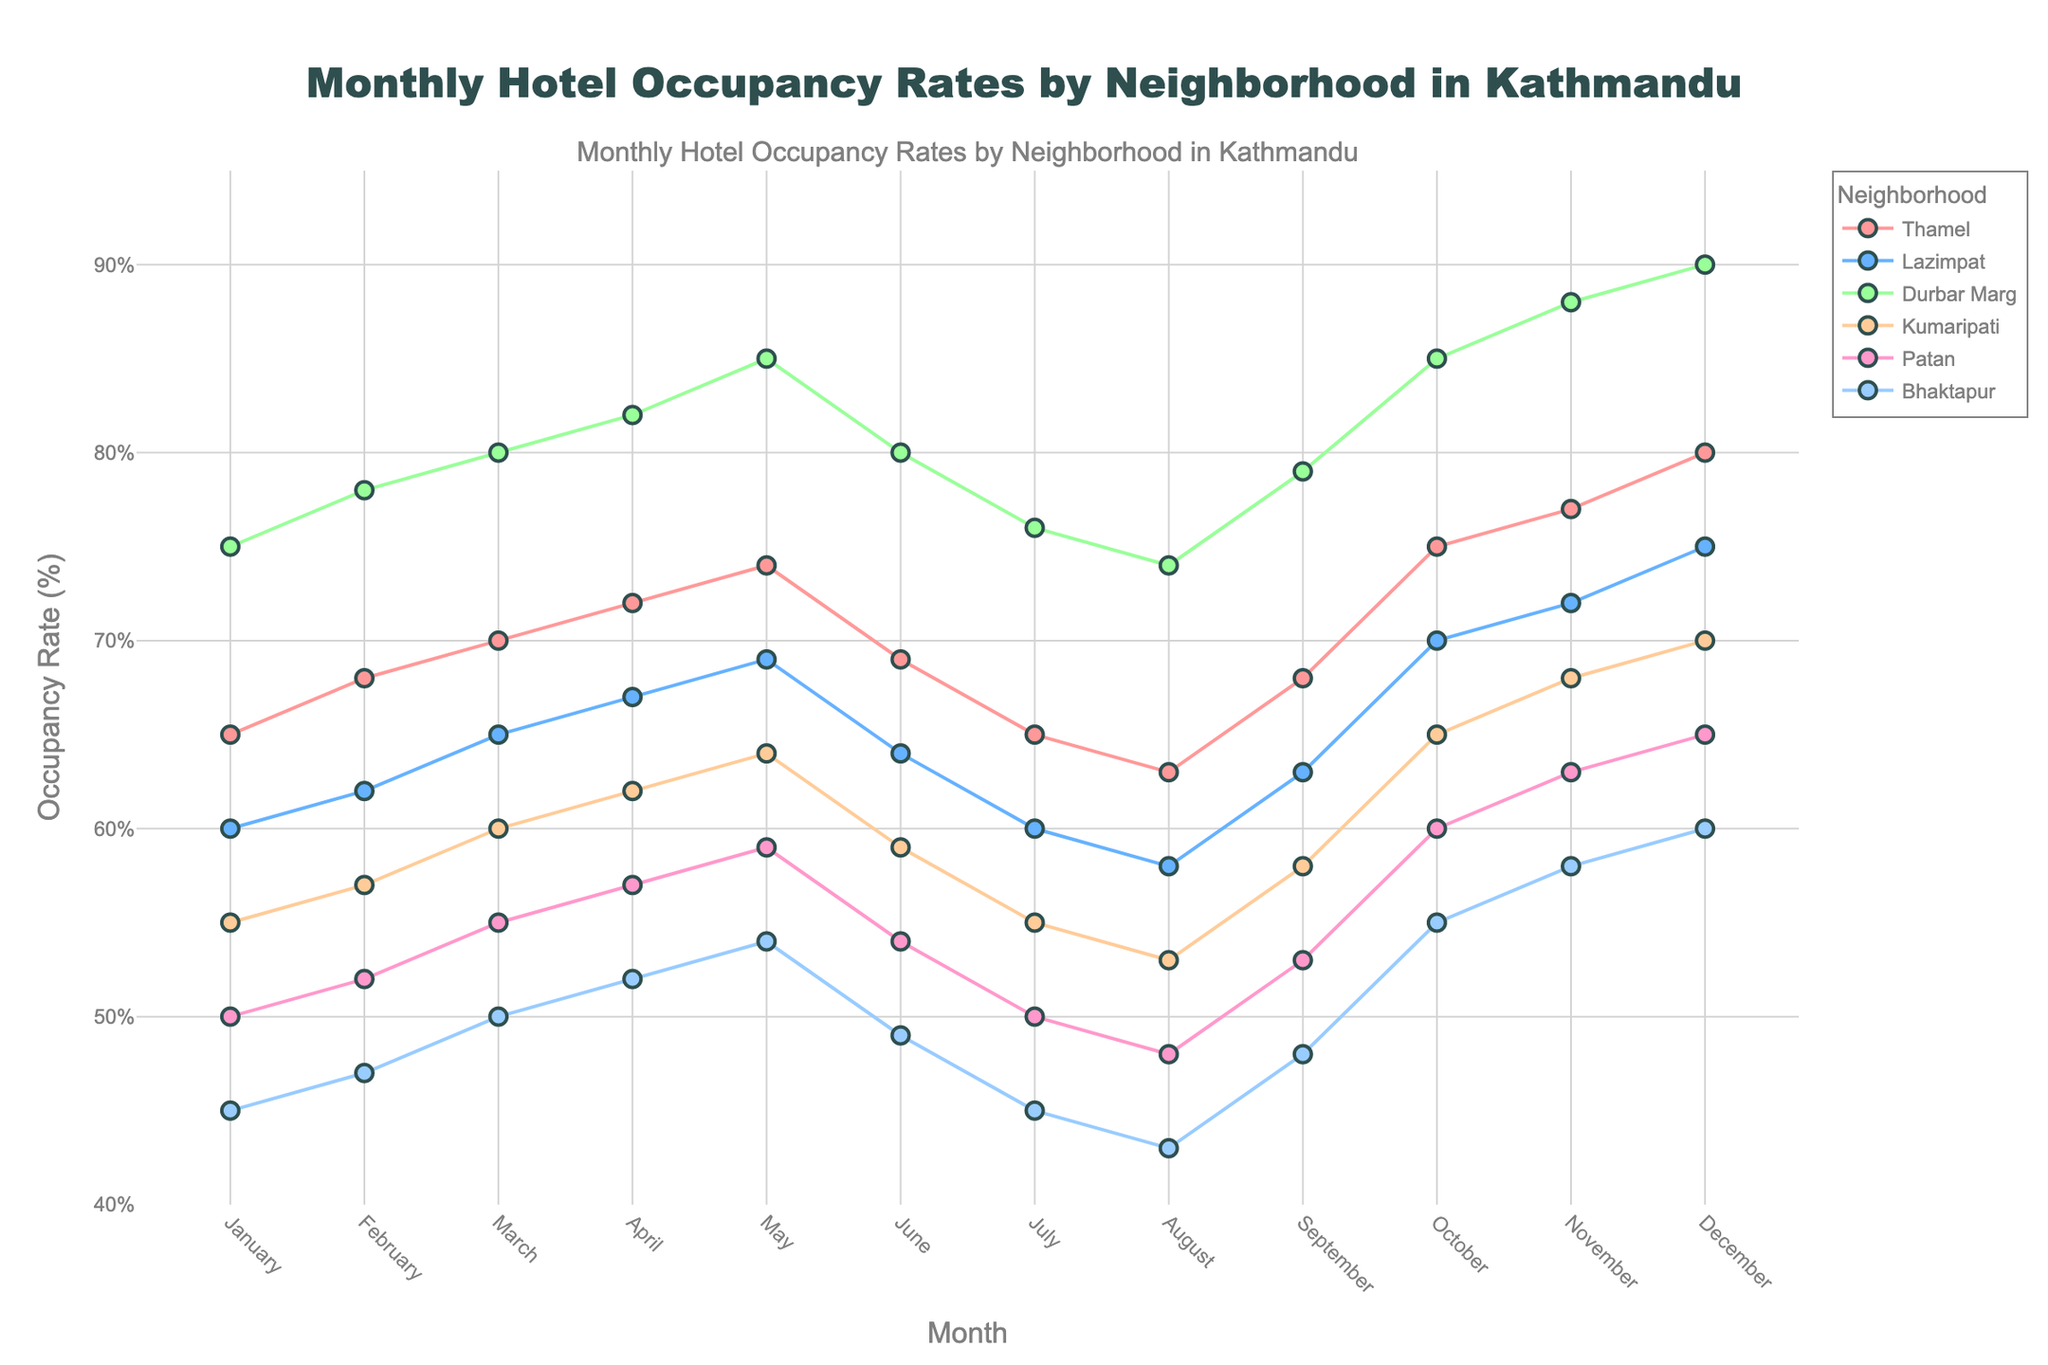What's the title of the figure? The title is typically displayed at the top of the figure. It summarizes the content of the chart.
Answer: Monthly Hotel Occupancy Rates by Neighborhood in Kathmandu Which neighborhood had the highest occupancy rate in December? To find the highest occupancy rate in December, look for the data points corresponding to December and compare the heights of the points.
Answer: Durbar Marg How does the occupancy rate trend for Thamel from January to December? Observe the markers connected by lines for Thamel. It starts at 65% in January, shows an increasing trend reaching around 80% in December.
Answer: Increasing trend In which month did Kumaripati have the lowest occupancy rate, and what was it? Look at the data points for Kumaripati and identify the month where the occupancy rate is lowest. The lowest data point for Kumaripati is at 53% in August.
Answer: August, 53% Compare the difference in occupancy rates between Bhaktapur and Durbar Marg in November. Find the data points for Bhaktapur and Durbar Marg in November and calculate the difference: Durbar Marg (88%), Bhaktapur (58%). The difference is 88 - 58 = 30%.
Answer: 30% Which neighborhood shows the most substantial increase in occupancy rate from August to September? Compare the difference in height between the August and September data points for each neighborhood and identify the one with the biggest increase.
Answer: Durbar Marg What is the general trend in occupancy rates for Patan and how does it compare to Thamel? Review the markers and lines for Patan and Thamel. Patan's occupancy rate generally increases from January to December but starts at a lower rate and grows less compared to Thamel.
Answer: Both increase, but Thamel has higher rates overall Which month has the smallest range of occupancy rates across all neighborhoods, and what is the range? Calculate the range (max - min) for each month across the neighborhoods by checking all data points for the same month. Identify which month has the smallest range and note the values.
Answer: March, range: (80 - 50) = 30% How do the occupancy rates in Lazimpat fluctuate throughout the year? Observe the markers connected by lines for Lazimpat. It starts at 60% in January, peaks at 75% in December, showing a general increase with some minor fluctuations.
Answer: Fluctuate but generally increase During which months does Bhaktapur consistently have the lowest occupancy rate compared to other neighborhoods? To determine the lowest occupancy rates, compare the data points for Bhaktapur with other neighborhoods for each month and identify the consistent lowest points.
Answer: January, February, March, July, August, September 